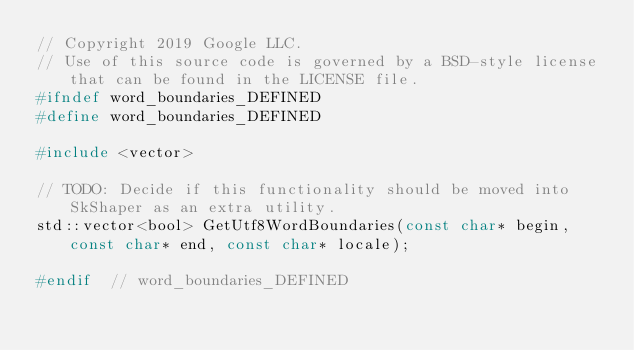Convert code to text. <code><loc_0><loc_0><loc_500><loc_500><_C_>// Copyright 2019 Google LLC.
// Use of this source code is governed by a BSD-style license that can be found in the LICENSE file.
#ifndef word_boundaries_DEFINED
#define word_boundaries_DEFINED

#include <vector>

// TODO: Decide if this functionality should be moved into SkShaper as an extra utility.
std::vector<bool> GetUtf8WordBoundaries(const char* begin, const char* end, const char* locale);

#endif  // word_boundaries_DEFINED
</code> 